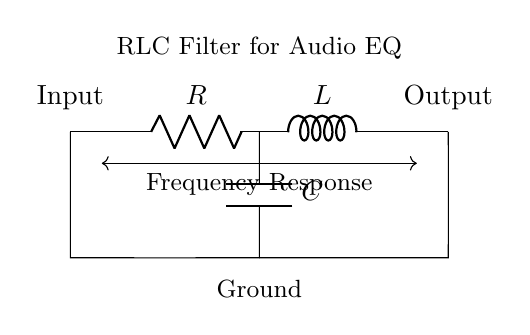What are the components in this circuit? The circuit consists of a resistor, an inductor, and a capacitor, as labeled in the diagram.
Answer: Resistor, Inductor, Capacitor What is the function of the capacitor in this circuit? The capacitor works to filter frequencies and stabilize voltage, depending on the audio signal.
Answer: Frequency filtering What type of filter does this RLC circuit represent? The RLC circuit is typically used as a band-pass filter, allowing certain frequency ranges to pass while attenuating others.
Answer: Band-pass filter How many terminals are there for input and output? There are two terminals, one for input and one for output, as indicated in the circuit.
Answer: Two What is the primary use of this RLC filter in studio equipment? This RLC filter is primarily used for audio equalization, shaping the audio signal to enhance sound quality.
Answer: Audio equalization What happens to frequencies outside of the desired range in this circuit? Frequencies outside of the desired range are attenuated, meaning they are reduced in amplitude by the filtering effect of the circuit.
Answer: Attenuated 